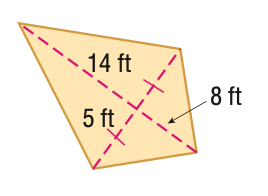Question: Find the area of the kite.
Choices:
A. 40
B. 70
C. 110
D. 220
Answer with the letter. Answer: C 